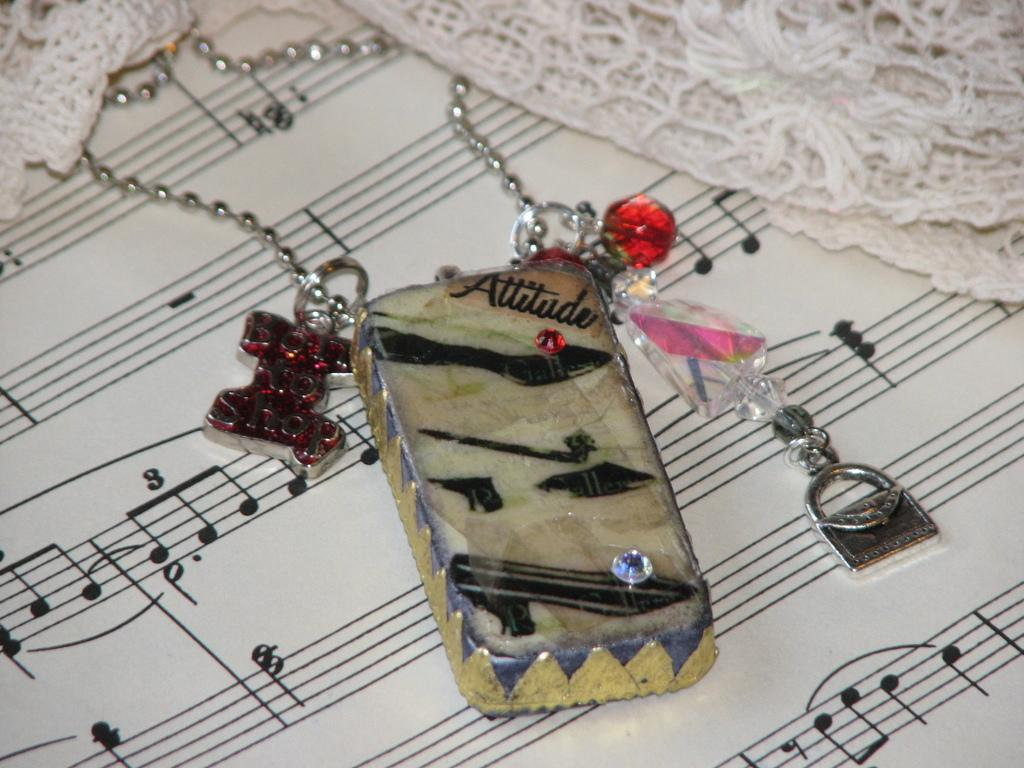What type of items are hanging from the chains in the image? There are pendants hanging from the chains in the image. What other type of items can be seen in the image? There are key chains in the image. On what surface are the chains and key chains placed? The chains and key chains are placed on a cloth. How many rocks are visible in the image? There are no rocks present in the image. Can you describe the flock of birds in the image? There is no flock of birds present in the image. 